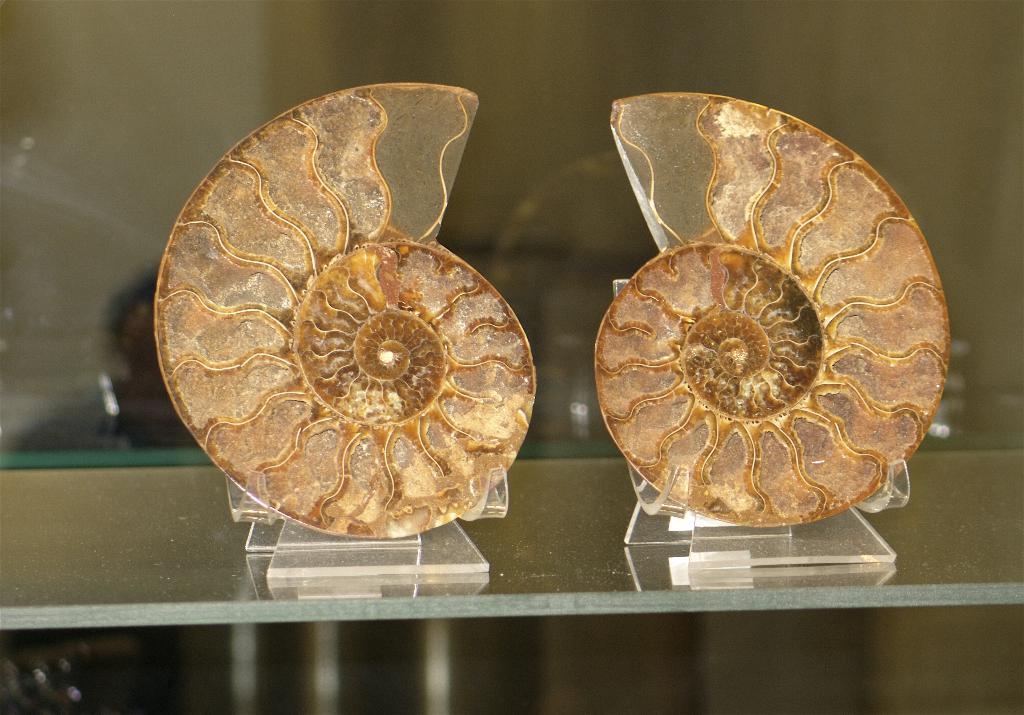Can you describe this image briefly? In this picture we can see two shields placed on a rack and in the background we can see a person and it is blurry. 